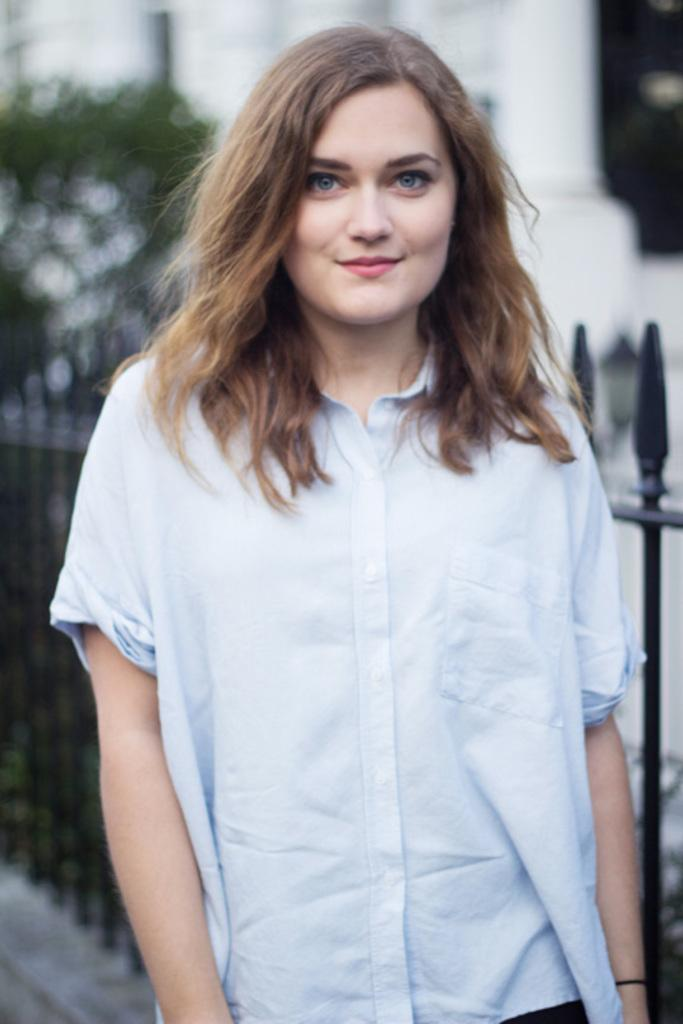Who is the main subject in the image? There is a girl in the image. What is the girl wearing? The girl is wearing a white shirt. What can be seen in the background of the image? There is a fence and a building in the background of the image. What is located on the left side of the image? There is a tree on the left side of the image. Can you tell me how many boys are present in the image? There is no boy present in the image; it features a girl. What type of earth can be seen in the image? There is no specific type of earth visible in the image; it is a general outdoor scene with a girl, a tree, and a background with a fence and a building. 